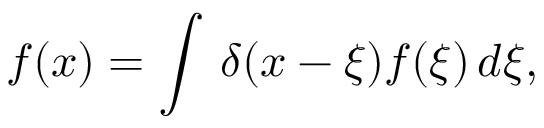<formula> <loc_0><loc_0><loc_500><loc_500>f ( x ) = \int \, \delta ( x - \xi ) f ( \xi ) \, d \xi ,</formula> 